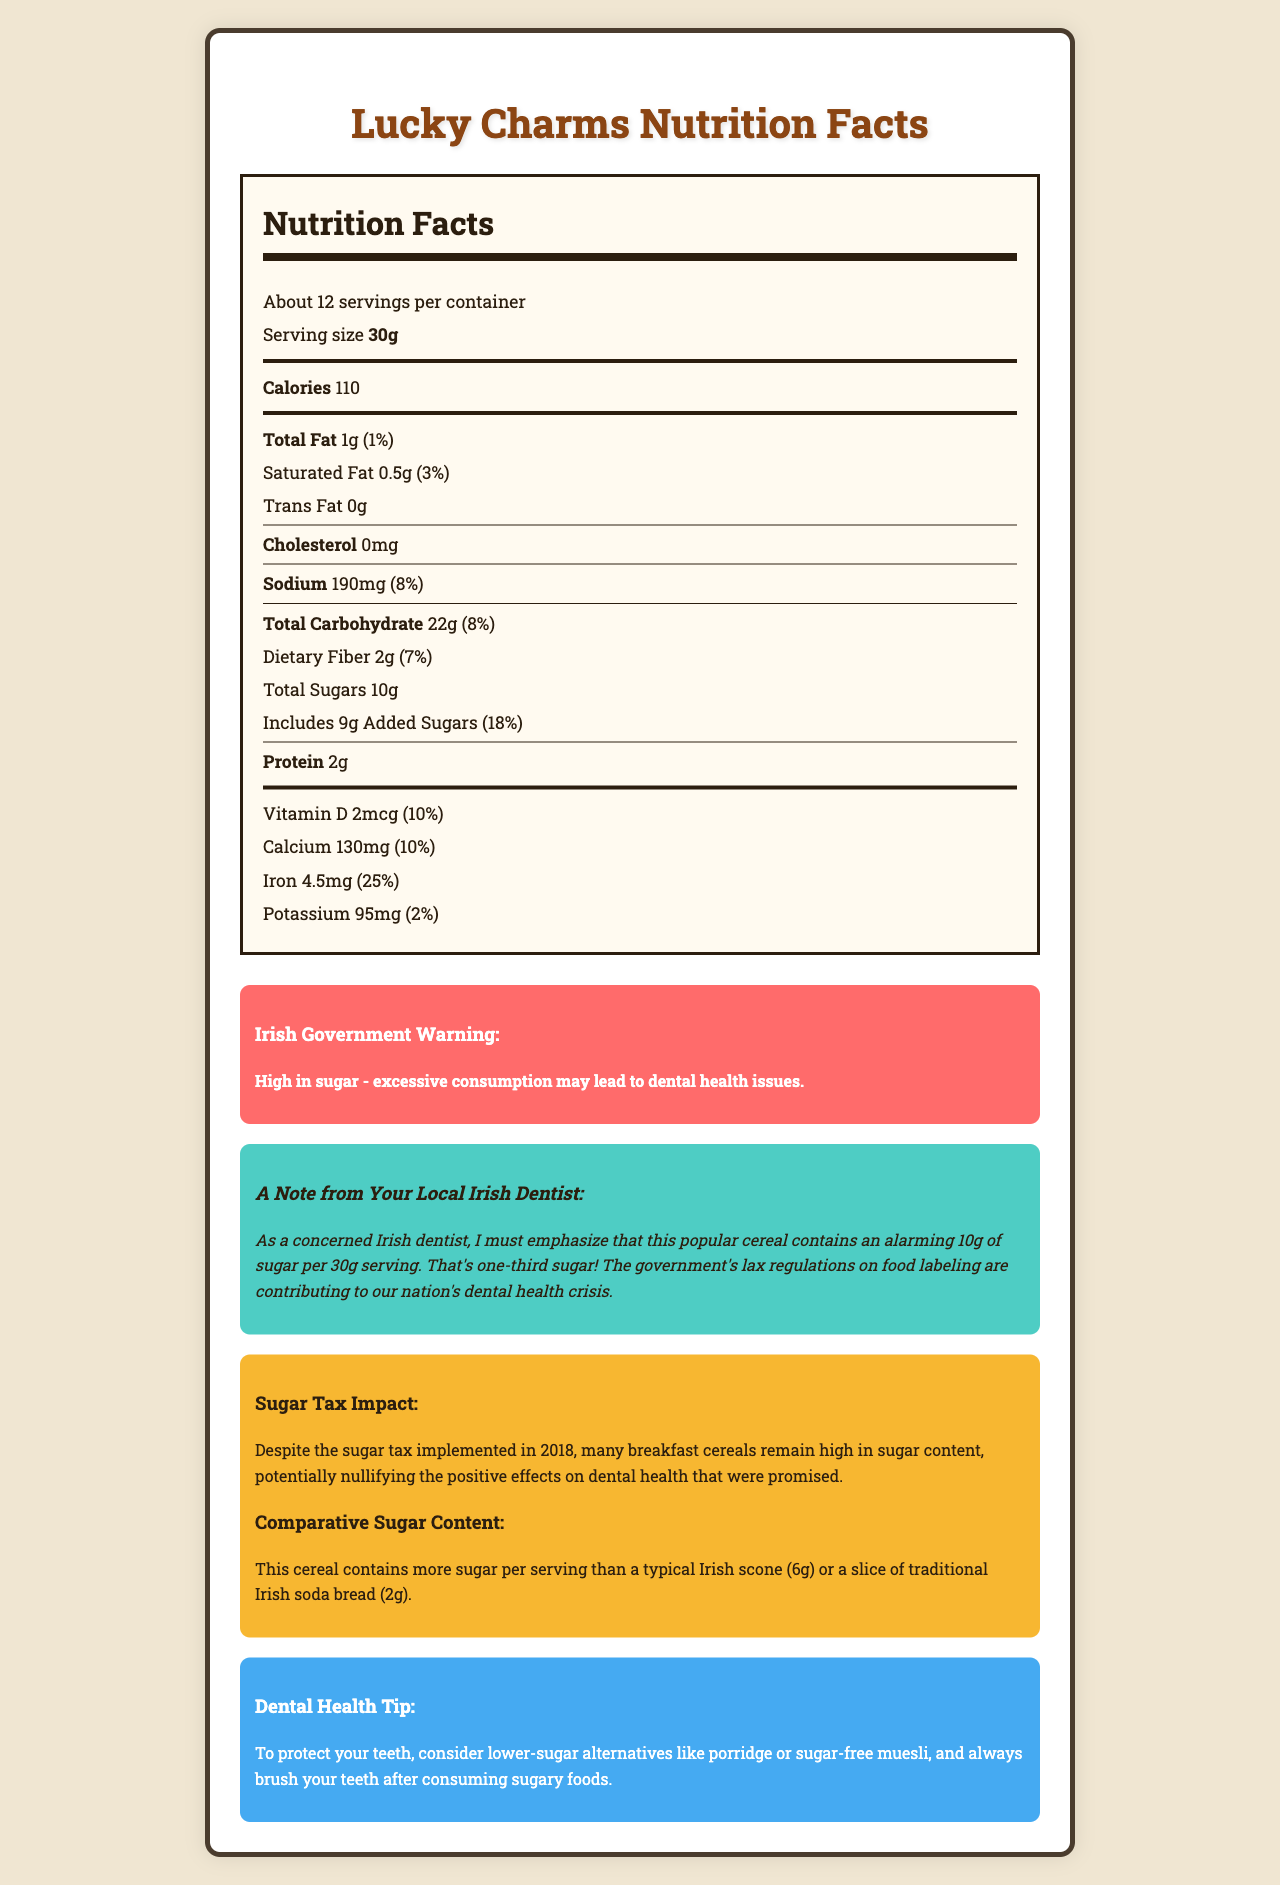what is the serving size of Lucky Charms? The document states that the serving size is 30g.
Answer: 30g how many servings are in the container? The document indicates there are about 12 servings per container.
Answer: About 12 how many grams of total sugars are in one serving? The document specifies that there are 10g of total sugars per 30g serving.
Answer: 10g what percentage of the daily value of added sugars does one serving contain? The document shows that one serving contains 18% of the daily value of added sugars.
Answer: 18% what is the total fat content per serving? The document mentions that the total fat content per serving is 1g.
Answer: 1g which of the following describes the amount of dietary fiber in one serving? A. 1g B. 2g C. 3g D. 4g The document indicates that the dietary fiber content per serving is 2g.
Answer: B how much calcium is in one serving of Lucky Charms? A. 50mg B. 100mg C. 130mg D. 200mg The document states that one serving contains 130mg of calcium.
Answer: C does Lucky Charms contain any trans fat? The document reports that there is 0g of trans fat in one serving.
Answer: No summarize the main concerns highlighted by the document regarding the consumption of this cereal. The document contains information on the nutrition facts of Lucky Charms, with a particular emphasis on the high sugar content. It also features a warning from the Irish government about the potential dental health implications of excessive sugar consumption and a note from a concerned Irish dentist. There are comparisons to other breakfast foods, comments on the impact of the sugar tax, and a tip to consider lower-sugar alternatives.
Answer: The main concerns highlighted by the document are the excessive sugar content in Lucky Charms, which could lead to dental health problems. Despite the sugar tax implemented in Ireland, the cereal remains high in sugar, with 10g of sugars per serving, including 9g of added sugars, which is 18% of the daily value. The document emphasizes the need for clearer food labeling regulations and suggests lower-sugar alternatives to protect dental health. where is the product manufactured? The document does not provide information on the location of the manufacturing of Lucky Charms.
Answer: Not enough information 